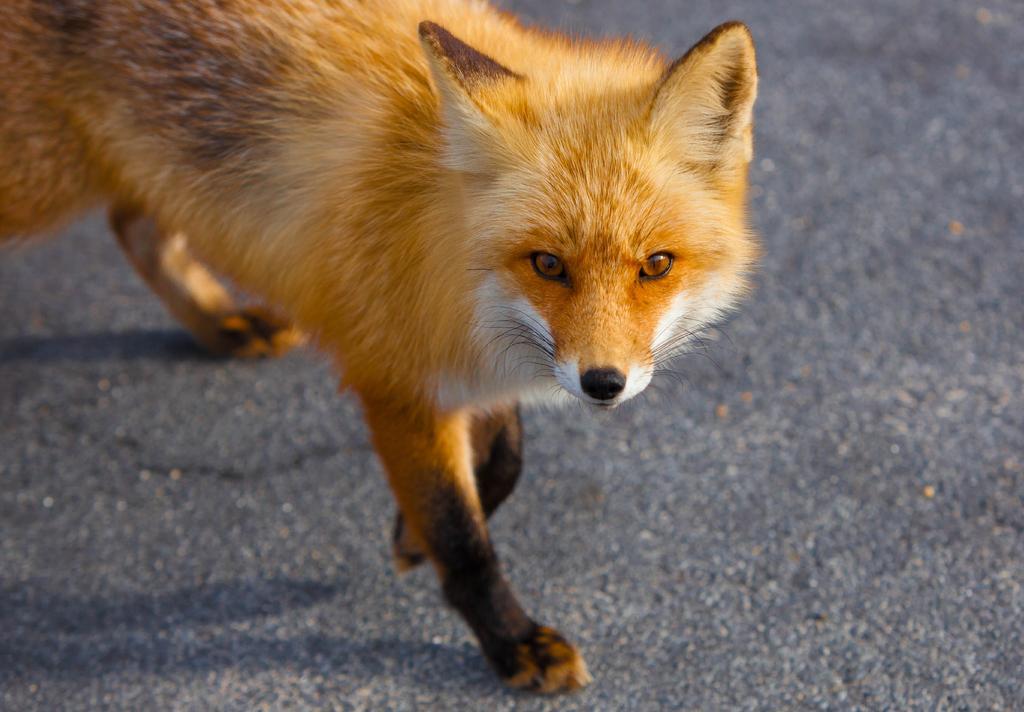Can you describe this image briefly? In the foreground of this picture, there is a fox walking on the road. 